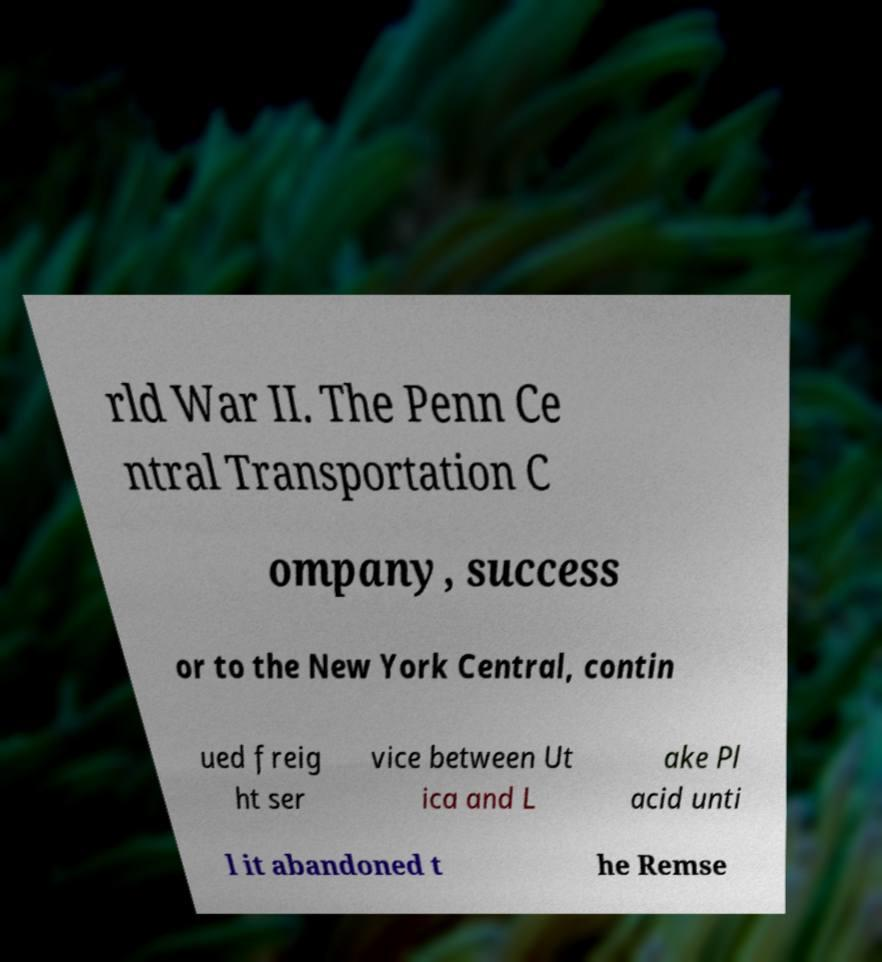Could you extract and type out the text from this image? rld War II. The Penn Ce ntral Transportation C ompany, success or to the New York Central, contin ued freig ht ser vice between Ut ica and L ake Pl acid unti l it abandoned t he Remse 